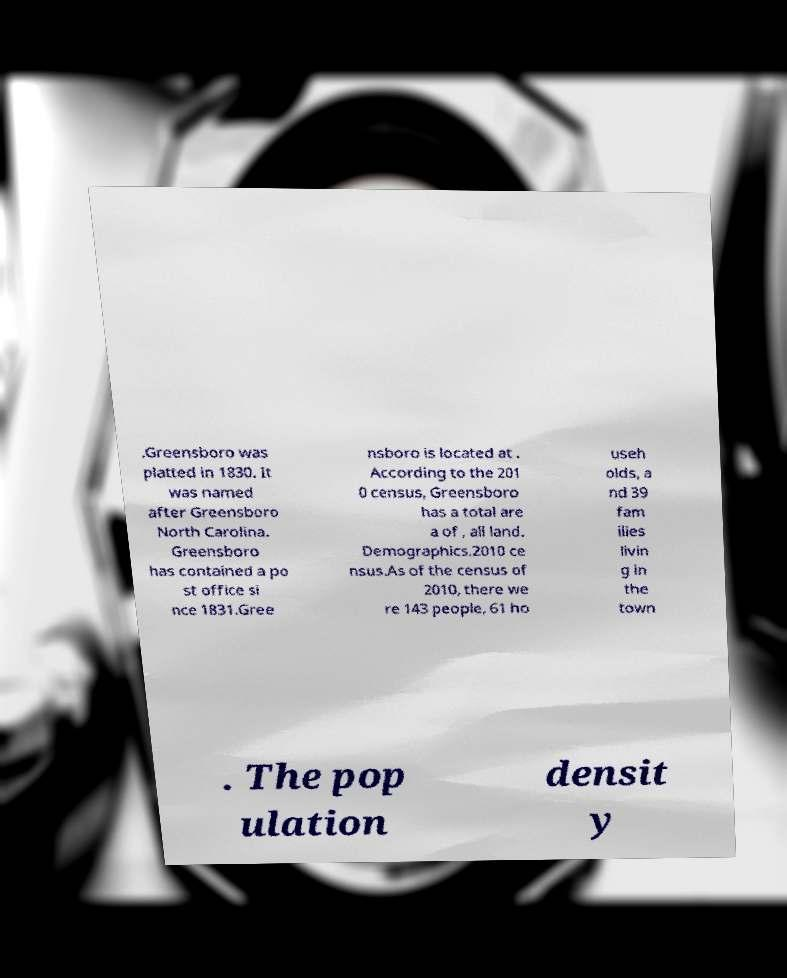What messages or text are displayed in this image? I need them in a readable, typed format. .Greensboro was platted in 1830. It was named after Greensboro North Carolina. Greensboro has contained a po st office si nce 1831.Gree nsboro is located at . According to the 201 0 census, Greensboro has a total are a of , all land. Demographics.2010 ce nsus.As of the census of 2010, there we re 143 people, 61 ho useh olds, a nd 39 fam ilies livin g in the town . The pop ulation densit y 